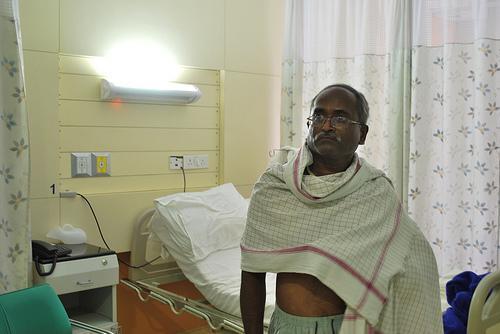How many lights are in thepicture?
Give a very brief answer. 1. How many people are in the picture?
Give a very brief answer. 1. 